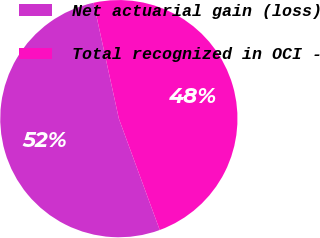Convert chart to OTSL. <chart><loc_0><loc_0><loc_500><loc_500><pie_chart><fcel>Net actuarial gain (loss)<fcel>Total recognized in OCI -<nl><fcel>52.18%<fcel>47.82%<nl></chart> 